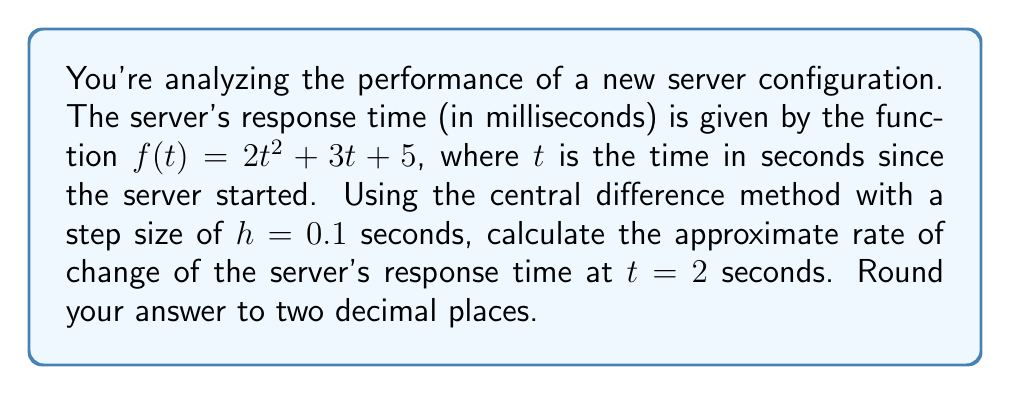Can you answer this question? To solve this problem, we'll use the central difference method for numerical differentiation. The formula for the central difference approximation of the first derivative is:

$$f'(t) \approx \frac{f(t+h) - f(t-h)}{2h}$$

Where $h$ is the step size.

Given:
- $f(t) = 2t^2 + 3t + 5$
- $t = 2$ seconds
- $h = 0.1$ seconds

Steps:
1) Calculate $f(t+h)$:
   $f(2+0.1) = f(2.1) = 2(2.1)^2 + 3(2.1) + 5 = 2(4.41) + 6.3 + 5 = 8.82 + 6.3 + 5 = 20.12$

2) Calculate $f(t-h)$:
   $f(2-0.1) = f(1.9) = 2(1.9)^2 + 3(1.9) + 5 = 2(3.61) + 5.7 + 5 = 7.22 + 5.7 + 5 = 17.92$

3) Apply the central difference formula:
   $$f'(2) \approx \frac{f(2.1) - f(1.9)}{2(0.1)} = \frac{20.12 - 17.92}{0.2} = \frac{2.2}{0.2} = 11$$

4) Round to two decimal places:
   $11.00$ ms/s

This result means that at $t=2$ seconds, the server's response time is increasing at a rate of approximately 11.00 milliseconds per second.
Answer: 11.00 ms/s 